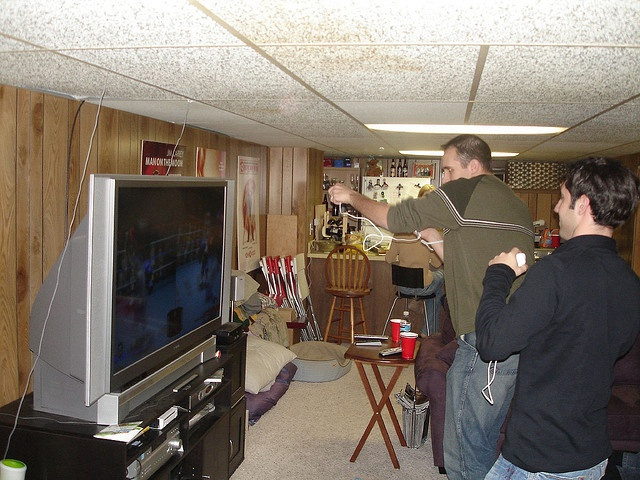Describe the objects in this image and their specific colors. I can see tv in beige, black, gray, darkgray, and lightgray tones, people in beige, black, tan, and gray tones, people in beige, gray, and tan tones, chair in beige, maroon, olive, and black tones, and chair in beige, black, darkgray, gray, and purple tones in this image. 